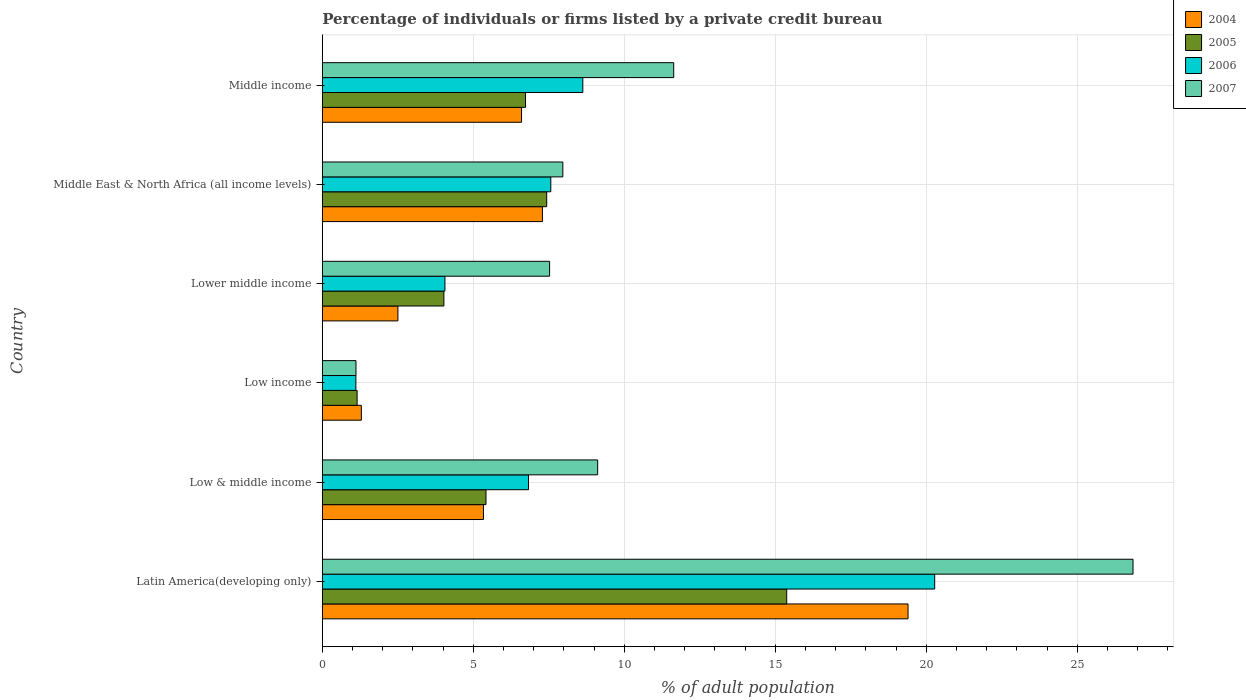How many different coloured bars are there?
Your response must be concise. 4. How many groups of bars are there?
Provide a short and direct response. 6. Are the number of bars on each tick of the Y-axis equal?
Ensure brevity in your answer.  Yes. How many bars are there on the 2nd tick from the top?
Offer a very short reply. 4. What is the label of the 6th group of bars from the top?
Your answer should be compact. Latin America(developing only). In how many cases, is the number of bars for a given country not equal to the number of legend labels?
Offer a very short reply. 0. What is the percentage of population listed by a private credit bureau in 2007 in Middle East & North Africa (all income levels)?
Your answer should be compact. 7.96. Across all countries, what is the maximum percentage of population listed by a private credit bureau in 2004?
Give a very brief answer. 19.39. Across all countries, what is the minimum percentage of population listed by a private credit bureau in 2004?
Give a very brief answer. 1.29. In which country was the percentage of population listed by a private credit bureau in 2004 maximum?
Give a very brief answer. Latin America(developing only). In which country was the percentage of population listed by a private credit bureau in 2005 minimum?
Your answer should be compact. Low income. What is the total percentage of population listed by a private credit bureau in 2004 in the graph?
Offer a terse response. 42.41. What is the difference between the percentage of population listed by a private credit bureau in 2004 in Low & middle income and that in Middle East & North Africa (all income levels)?
Make the answer very short. -1.95. What is the difference between the percentage of population listed by a private credit bureau in 2005 in Latin America(developing only) and the percentage of population listed by a private credit bureau in 2004 in Lower middle income?
Your answer should be very brief. 12.87. What is the average percentage of population listed by a private credit bureau in 2005 per country?
Provide a succinct answer. 6.69. What is the difference between the percentage of population listed by a private credit bureau in 2006 and percentage of population listed by a private credit bureau in 2005 in Low income?
Your answer should be very brief. -0.04. What is the ratio of the percentage of population listed by a private credit bureau in 2004 in Latin America(developing only) to that in Lower middle income?
Give a very brief answer. 7.75. Is the percentage of population listed by a private credit bureau in 2004 in Low income less than that in Middle East & North Africa (all income levels)?
Give a very brief answer. Yes. What is the difference between the highest and the second highest percentage of population listed by a private credit bureau in 2007?
Give a very brief answer. 15.21. What is the difference between the highest and the lowest percentage of population listed by a private credit bureau in 2007?
Provide a short and direct response. 25.73. In how many countries, is the percentage of population listed by a private credit bureau in 2007 greater than the average percentage of population listed by a private credit bureau in 2007 taken over all countries?
Keep it short and to the point. 2. Is it the case that in every country, the sum of the percentage of population listed by a private credit bureau in 2007 and percentage of population listed by a private credit bureau in 2005 is greater than the sum of percentage of population listed by a private credit bureau in 2004 and percentage of population listed by a private credit bureau in 2006?
Your response must be concise. No. What does the 2nd bar from the top in Low income represents?
Your answer should be compact. 2006. What does the 3rd bar from the bottom in Middle income represents?
Your answer should be very brief. 2006. How many bars are there?
Your response must be concise. 24. How many countries are there in the graph?
Offer a terse response. 6. What is the difference between two consecutive major ticks on the X-axis?
Make the answer very short. 5. Are the values on the major ticks of X-axis written in scientific E-notation?
Your answer should be very brief. No. Does the graph contain any zero values?
Offer a terse response. No. Does the graph contain grids?
Ensure brevity in your answer.  Yes. Where does the legend appear in the graph?
Make the answer very short. Top right. How many legend labels are there?
Your answer should be compact. 4. What is the title of the graph?
Offer a very short reply. Percentage of individuals or firms listed by a private credit bureau. Does "1992" appear as one of the legend labels in the graph?
Your answer should be compact. No. What is the label or title of the X-axis?
Your answer should be very brief. % of adult population. What is the label or title of the Y-axis?
Make the answer very short. Country. What is the % of adult population in 2004 in Latin America(developing only)?
Offer a terse response. 19.39. What is the % of adult population of 2005 in Latin America(developing only)?
Your answer should be very brief. 15.38. What is the % of adult population in 2006 in Latin America(developing only)?
Offer a very short reply. 20.28. What is the % of adult population of 2007 in Latin America(developing only)?
Offer a very short reply. 26.84. What is the % of adult population in 2004 in Low & middle income?
Your response must be concise. 5.34. What is the % of adult population of 2005 in Low & middle income?
Your answer should be very brief. 5.42. What is the % of adult population in 2006 in Low & middle income?
Your answer should be compact. 6.83. What is the % of adult population in 2007 in Low & middle income?
Give a very brief answer. 9.12. What is the % of adult population of 2004 in Low income?
Give a very brief answer. 1.29. What is the % of adult population in 2005 in Low income?
Provide a succinct answer. 1.15. What is the % of adult population of 2006 in Low income?
Your response must be concise. 1.11. What is the % of adult population of 2007 in Low income?
Your response must be concise. 1.11. What is the % of adult population of 2004 in Lower middle income?
Make the answer very short. 2.5. What is the % of adult population in 2005 in Lower middle income?
Offer a terse response. 4.03. What is the % of adult population in 2006 in Lower middle income?
Give a very brief answer. 4.06. What is the % of adult population of 2007 in Lower middle income?
Give a very brief answer. 7.53. What is the % of adult population of 2004 in Middle East & North Africa (all income levels)?
Make the answer very short. 7.29. What is the % of adult population in 2005 in Middle East & North Africa (all income levels)?
Provide a short and direct response. 7.43. What is the % of adult population of 2006 in Middle East & North Africa (all income levels)?
Your answer should be compact. 7.56. What is the % of adult population in 2007 in Middle East & North Africa (all income levels)?
Offer a very short reply. 7.96. What is the % of adult population in 2004 in Middle income?
Your answer should be very brief. 6.6. What is the % of adult population in 2005 in Middle income?
Make the answer very short. 6.73. What is the % of adult population in 2006 in Middle income?
Keep it short and to the point. 8.62. What is the % of adult population in 2007 in Middle income?
Ensure brevity in your answer.  11.63. Across all countries, what is the maximum % of adult population of 2004?
Provide a succinct answer. 19.39. Across all countries, what is the maximum % of adult population in 2005?
Give a very brief answer. 15.38. Across all countries, what is the maximum % of adult population of 2006?
Make the answer very short. 20.28. Across all countries, what is the maximum % of adult population in 2007?
Ensure brevity in your answer.  26.84. Across all countries, what is the minimum % of adult population in 2004?
Give a very brief answer. 1.29. Across all countries, what is the minimum % of adult population of 2005?
Make the answer very short. 1.15. Across all countries, what is the minimum % of adult population of 2006?
Your answer should be compact. 1.11. Across all countries, what is the minimum % of adult population in 2007?
Your answer should be very brief. 1.11. What is the total % of adult population in 2004 in the graph?
Ensure brevity in your answer.  42.41. What is the total % of adult population in 2005 in the graph?
Offer a terse response. 40.13. What is the total % of adult population of 2006 in the graph?
Your response must be concise. 48.46. What is the total % of adult population in 2007 in the graph?
Offer a very short reply. 64.2. What is the difference between the % of adult population in 2004 in Latin America(developing only) and that in Low & middle income?
Provide a succinct answer. 14.06. What is the difference between the % of adult population in 2005 in Latin America(developing only) and that in Low & middle income?
Give a very brief answer. 9.96. What is the difference between the % of adult population in 2006 in Latin America(developing only) and that in Low & middle income?
Make the answer very short. 13.45. What is the difference between the % of adult population in 2007 in Latin America(developing only) and that in Low & middle income?
Offer a very short reply. 17.73. What is the difference between the % of adult population in 2004 in Latin America(developing only) and that in Low income?
Your answer should be very brief. 18.1. What is the difference between the % of adult population of 2005 in Latin America(developing only) and that in Low income?
Your answer should be compact. 14.22. What is the difference between the % of adult population in 2006 in Latin America(developing only) and that in Low income?
Give a very brief answer. 19.17. What is the difference between the % of adult population of 2007 in Latin America(developing only) and that in Low income?
Offer a very short reply. 25.73. What is the difference between the % of adult population of 2004 in Latin America(developing only) and that in Lower middle income?
Your answer should be very brief. 16.89. What is the difference between the % of adult population in 2005 in Latin America(developing only) and that in Lower middle income?
Ensure brevity in your answer.  11.35. What is the difference between the % of adult population of 2006 in Latin America(developing only) and that in Lower middle income?
Make the answer very short. 16.22. What is the difference between the % of adult population of 2007 in Latin America(developing only) and that in Lower middle income?
Keep it short and to the point. 19.32. What is the difference between the % of adult population of 2004 in Latin America(developing only) and that in Middle East & North Africa (all income levels)?
Give a very brief answer. 12.11. What is the difference between the % of adult population in 2005 in Latin America(developing only) and that in Middle East & North Africa (all income levels)?
Your answer should be very brief. 7.95. What is the difference between the % of adult population of 2006 in Latin America(developing only) and that in Middle East & North Africa (all income levels)?
Keep it short and to the point. 12.71. What is the difference between the % of adult population in 2007 in Latin America(developing only) and that in Middle East & North Africa (all income levels)?
Offer a very short reply. 18.88. What is the difference between the % of adult population of 2004 in Latin America(developing only) and that in Middle income?
Provide a short and direct response. 12.8. What is the difference between the % of adult population of 2005 in Latin America(developing only) and that in Middle income?
Your response must be concise. 8.65. What is the difference between the % of adult population in 2006 in Latin America(developing only) and that in Middle income?
Keep it short and to the point. 11.65. What is the difference between the % of adult population in 2007 in Latin America(developing only) and that in Middle income?
Keep it short and to the point. 15.21. What is the difference between the % of adult population in 2004 in Low & middle income and that in Low income?
Provide a short and direct response. 4.04. What is the difference between the % of adult population of 2005 in Low & middle income and that in Low income?
Provide a short and direct response. 4.27. What is the difference between the % of adult population in 2006 in Low & middle income and that in Low income?
Offer a terse response. 5.72. What is the difference between the % of adult population of 2007 in Low & middle income and that in Low income?
Provide a succinct answer. 8. What is the difference between the % of adult population of 2004 in Low & middle income and that in Lower middle income?
Offer a terse response. 2.83. What is the difference between the % of adult population in 2005 in Low & middle income and that in Lower middle income?
Give a very brief answer. 1.39. What is the difference between the % of adult population of 2006 in Low & middle income and that in Lower middle income?
Your answer should be compact. 2.77. What is the difference between the % of adult population in 2007 in Low & middle income and that in Lower middle income?
Your response must be concise. 1.59. What is the difference between the % of adult population of 2004 in Low & middle income and that in Middle East & North Africa (all income levels)?
Offer a terse response. -1.95. What is the difference between the % of adult population of 2005 in Low & middle income and that in Middle East & North Africa (all income levels)?
Provide a short and direct response. -2.01. What is the difference between the % of adult population of 2006 in Low & middle income and that in Middle East & North Africa (all income levels)?
Provide a succinct answer. -0.74. What is the difference between the % of adult population of 2007 in Low & middle income and that in Middle East & North Africa (all income levels)?
Your answer should be very brief. 1.15. What is the difference between the % of adult population of 2004 in Low & middle income and that in Middle income?
Offer a very short reply. -1.26. What is the difference between the % of adult population in 2005 in Low & middle income and that in Middle income?
Keep it short and to the point. -1.31. What is the difference between the % of adult population of 2006 in Low & middle income and that in Middle income?
Offer a very short reply. -1.8. What is the difference between the % of adult population of 2007 in Low & middle income and that in Middle income?
Provide a short and direct response. -2.52. What is the difference between the % of adult population in 2004 in Low income and that in Lower middle income?
Keep it short and to the point. -1.21. What is the difference between the % of adult population of 2005 in Low income and that in Lower middle income?
Make the answer very short. -2.87. What is the difference between the % of adult population of 2006 in Low income and that in Lower middle income?
Offer a very short reply. -2.95. What is the difference between the % of adult population of 2007 in Low income and that in Lower middle income?
Provide a succinct answer. -6.41. What is the difference between the % of adult population of 2004 in Low income and that in Middle East & North Africa (all income levels)?
Keep it short and to the point. -6. What is the difference between the % of adult population in 2005 in Low income and that in Middle East & North Africa (all income levels)?
Offer a very short reply. -6.28. What is the difference between the % of adult population of 2006 in Low income and that in Middle East & North Africa (all income levels)?
Offer a very short reply. -6.45. What is the difference between the % of adult population in 2007 in Low income and that in Middle East & North Africa (all income levels)?
Make the answer very short. -6.85. What is the difference between the % of adult population in 2004 in Low income and that in Middle income?
Provide a short and direct response. -5.3. What is the difference between the % of adult population of 2005 in Low income and that in Middle income?
Make the answer very short. -5.58. What is the difference between the % of adult population in 2006 in Low income and that in Middle income?
Your response must be concise. -7.51. What is the difference between the % of adult population in 2007 in Low income and that in Middle income?
Keep it short and to the point. -10.52. What is the difference between the % of adult population in 2004 in Lower middle income and that in Middle East & North Africa (all income levels)?
Offer a very short reply. -4.79. What is the difference between the % of adult population in 2005 in Lower middle income and that in Middle East & North Africa (all income levels)?
Your answer should be very brief. -3.4. What is the difference between the % of adult population in 2006 in Lower middle income and that in Middle East & North Africa (all income levels)?
Offer a terse response. -3.51. What is the difference between the % of adult population of 2007 in Lower middle income and that in Middle East & North Africa (all income levels)?
Your answer should be very brief. -0.44. What is the difference between the % of adult population of 2004 in Lower middle income and that in Middle income?
Ensure brevity in your answer.  -4.09. What is the difference between the % of adult population of 2005 in Lower middle income and that in Middle income?
Offer a very short reply. -2.7. What is the difference between the % of adult population of 2006 in Lower middle income and that in Middle income?
Your answer should be very brief. -4.57. What is the difference between the % of adult population in 2007 in Lower middle income and that in Middle income?
Offer a very short reply. -4.11. What is the difference between the % of adult population in 2004 in Middle East & North Africa (all income levels) and that in Middle income?
Provide a succinct answer. 0.69. What is the difference between the % of adult population of 2005 in Middle East & North Africa (all income levels) and that in Middle income?
Ensure brevity in your answer.  0.7. What is the difference between the % of adult population in 2006 in Middle East & North Africa (all income levels) and that in Middle income?
Offer a very short reply. -1.06. What is the difference between the % of adult population of 2007 in Middle East & North Africa (all income levels) and that in Middle income?
Your response must be concise. -3.67. What is the difference between the % of adult population in 2004 in Latin America(developing only) and the % of adult population in 2005 in Low & middle income?
Offer a very short reply. 13.97. What is the difference between the % of adult population in 2004 in Latin America(developing only) and the % of adult population in 2006 in Low & middle income?
Give a very brief answer. 12.57. What is the difference between the % of adult population in 2004 in Latin America(developing only) and the % of adult population in 2007 in Low & middle income?
Offer a terse response. 10.28. What is the difference between the % of adult population in 2005 in Latin America(developing only) and the % of adult population in 2006 in Low & middle income?
Provide a short and direct response. 8.55. What is the difference between the % of adult population of 2005 in Latin America(developing only) and the % of adult population of 2007 in Low & middle income?
Provide a short and direct response. 6.26. What is the difference between the % of adult population in 2006 in Latin America(developing only) and the % of adult population in 2007 in Low & middle income?
Ensure brevity in your answer.  11.16. What is the difference between the % of adult population of 2004 in Latin America(developing only) and the % of adult population of 2005 in Low income?
Ensure brevity in your answer.  18.24. What is the difference between the % of adult population in 2004 in Latin America(developing only) and the % of adult population in 2006 in Low income?
Your response must be concise. 18.28. What is the difference between the % of adult population in 2004 in Latin America(developing only) and the % of adult population in 2007 in Low income?
Provide a short and direct response. 18.28. What is the difference between the % of adult population of 2005 in Latin America(developing only) and the % of adult population of 2006 in Low income?
Offer a terse response. 14.27. What is the difference between the % of adult population of 2005 in Latin America(developing only) and the % of adult population of 2007 in Low income?
Ensure brevity in your answer.  14.26. What is the difference between the % of adult population in 2006 in Latin America(developing only) and the % of adult population in 2007 in Low income?
Your answer should be very brief. 19.16. What is the difference between the % of adult population in 2004 in Latin America(developing only) and the % of adult population in 2005 in Lower middle income?
Give a very brief answer. 15.37. What is the difference between the % of adult population of 2004 in Latin America(developing only) and the % of adult population of 2006 in Lower middle income?
Your answer should be compact. 15.33. What is the difference between the % of adult population of 2004 in Latin America(developing only) and the % of adult population of 2007 in Lower middle income?
Your answer should be very brief. 11.87. What is the difference between the % of adult population of 2005 in Latin America(developing only) and the % of adult population of 2006 in Lower middle income?
Give a very brief answer. 11.32. What is the difference between the % of adult population of 2005 in Latin America(developing only) and the % of adult population of 2007 in Lower middle income?
Your answer should be very brief. 7.85. What is the difference between the % of adult population of 2006 in Latin America(developing only) and the % of adult population of 2007 in Lower middle income?
Your response must be concise. 12.75. What is the difference between the % of adult population in 2004 in Latin America(developing only) and the % of adult population in 2005 in Middle East & North Africa (all income levels)?
Ensure brevity in your answer.  11.96. What is the difference between the % of adult population of 2004 in Latin America(developing only) and the % of adult population of 2006 in Middle East & North Africa (all income levels)?
Your answer should be compact. 11.83. What is the difference between the % of adult population of 2004 in Latin America(developing only) and the % of adult population of 2007 in Middle East & North Africa (all income levels)?
Give a very brief answer. 11.43. What is the difference between the % of adult population in 2005 in Latin America(developing only) and the % of adult population in 2006 in Middle East & North Africa (all income levels)?
Offer a very short reply. 7.81. What is the difference between the % of adult population in 2005 in Latin America(developing only) and the % of adult population in 2007 in Middle East & North Africa (all income levels)?
Ensure brevity in your answer.  7.41. What is the difference between the % of adult population in 2006 in Latin America(developing only) and the % of adult population in 2007 in Middle East & North Africa (all income levels)?
Provide a short and direct response. 12.31. What is the difference between the % of adult population in 2004 in Latin America(developing only) and the % of adult population in 2005 in Middle income?
Your answer should be compact. 12.66. What is the difference between the % of adult population of 2004 in Latin America(developing only) and the % of adult population of 2006 in Middle income?
Your answer should be very brief. 10.77. What is the difference between the % of adult population of 2004 in Latin America(developing only) and the % of adult population of 2007 in Middle income?
Make the answer very short. 7.76. What is the difference between the % of adult population in 2005 in Latin America(developing only) and the % of adult population in 2006 in Middle income?
Your answer should be compact. 6.75. What is the difference between the % of adult population of 2005 in Latin America(developing only) and the % of adult population of 2007 in Middle income?
Make the answer very short. 3.74. What is the difference between the % of adult population of 2006 in Latin America(developing only) and the % of adult population of 2007 in Middle income?
Your answer should be very brief. 8.64. What is the difference between the % of adult population of 2004 in Low & middle income and the % of adult population of 2005 in Low income?
Give a very brief answer. 4.18. What is the difference between the % of adult population in 2004 in Low & middle income and the % of adult population in 2006 in Low income?
Your response must be concise. 4.22. What is the difference between the % of adult population of 2004 in Low & middle income and the % of adult population of 2007 in Low income?
Your response must be concise. 4.22. What is the difference between the % of adult population of 2005 in Low & middle income and the % of adult population of 2006 in Low income?
Your response must be concise. 4.31. What is the difference between the % of adult population of 2005 in Low & middle income and the % of adult population of 2007 in Low income?
Offer a very short reply. 4.3. What is the difference between the % of adult population in 2006 in Low & middle income and the % of adult population in 2007 in Low income?
Provide a short and direct response. 5.71. What is the difference between the % of adult population of 2004 in Low & middle income and the % of adult population of 2005 in Lower middle income?
Your answer should be compact. 1.31. What is the difference between the % of adult population of 2004 in Low & middle income and the % of adult population of 2006 in Lower middle income?
Ensure brevity in your answer.  1.28. What is the difference between the % of adult population in 2004 in Low & middle income and the % of adult population in 2007 in Lower middle income?
Your response must be concise. -2.19. What is the difference between the % of adult population of 2005 in Low & middle income and the % of adult population of 2006 in Lower middle income?
Give a very brief answer. 1.36. What is the difference between the % of adult population of 2005 in Low & middle income and the % of adult population of 2007 in Lower middle income?
Offer a terse response. -2.11. What is the difference between the % of adult population of 2006 in Low & middle income and the % of adult population of 2007 in Lower middle income?
Keep it short and to the point. -0.7. What is the difference between the % of adult population in 2004 in Low & middle income and the % of adult population in 2005 in Middle East & North Africa (all income levels)?
Your answer should be compact. -2.09. What is the difference between the % of adult population of 2004 in Low & middle income and the % of adult population of 2006 in Middle East & North Africa (all income levels)?
Make the answer very short. -2.23. What is the difference between the % of adult population in 2004 in Low & middle income and the % of adult population in 2007 in Middle East & North Africa (all income levels)?
Ensure brevity in your answer.  -2.63. What is the difference between the % of adult population in 2005 in Low & middle income and the % of adult population in 2006 in Middle East & North Africa (all income levels)?
Offer a terse response. -2.15. What is the difference between the % of adult population of 2005 in Low & middle income and the % of adult population of 2007 in Middle East & North Africa (all income levels)?
Keep it short and to the point. -2.54. What is the difference between the % of adult population in 2006 in Low & middle income and the % of adult population in 2007 in Middle East & North Africa (all income levels)?
Your answer should be compact. -1.14. What is the difference between the % of adult population of 2004 in Low & middle income and the % of adult population of 2005 in Middle income?
Give a very brief answer. -1.39. What is the difference between the % of adult population in 2004 in Low & middle income and the % of adult population in 2006 in Middle income?
Give a very brief answer. -3.29. What is the difference between the % of adult population of 2004 in Low & middle income and the % of adult population of 2007 in Middle income?
Your response must be concise. -6.3. What is the difference between the % of adult population in 2005 in Low & middle income and the % of adult population in 2006 in Middle income?
Your answer should be very brief. -3.21. What is the difference between the % of adult population of 2005 in Low & middle income and the % of adult population of 2007 in Middle income?
Your answer should be compact. -6.22. What is the difference between the % of adult population in 2006 in Low & middle income and the % of adult population in 2007 in Middle income?
Your answer should be compact. -4.81. What is the difference between the % of adult population of 2004 in Low income and the % of adult population of 2005 in Lower middle income?
Provide a short and direct response. -2.73. What is the difference between the % of adult population in 2004 in Low income and the % of adult population in 2006 in Lower middle income?
Your answer should be very brief. -2.77. What is the difference between the % of adult population in 2004 in Low income and the % of adult population in 2007 in Lower middle income?
Offer a terse response. -6.23. What is the difference between the % of adult population in 2005 in Low income and the % of adult population in 2006 in Lower middle income?
Offer a very short reply. -2.91. What is the difference between the % of adult population of 2005 in Low income and the % of adult population of 2007 in Lower middle income?
Your response must be concise. -6.37. What is the difference between the % of adult population in 2006 in Low income and the % of adult population in 2007 in Lower middle income?
Make the answer very short. -6.41. What is the difference between the % of adult population in 2004 in Low income and the % of adult population in 2005 in Middle East & North Africa (all income levels)?
Provide a succinct answer. -6.14. What is the difference between the % of adult population of 2004 in Low income and the % of adult population of 2006 in Middle East & North Africa (all income levels)?
Your answer should be very brief. -6.27. What is the difference between the % of adult population in 2004 in Low income and the % of adult population in 2007 in Middle East & North Africa (all income levels)?
Your answer should be compact. -6.67. What is the difference between the % of adult population of 2005 in Low income and the % of adult population of 2006 in Middle East & North Africa (all income levels)?
Provide a succinct answer. -6.41. What is the difference between the % of adult population of 2005 in Low income and the % of adult population of 2007 in Middle East & North Africa (all income levels)?
Your answer should be compact. -6.81. What is the difference between the % of adult population of 2006 in Low income and the % of adult population of 2007 in Middle East & North Africa (all income levels)?
Ensure brevity in your answer.  -6.85. What is the difference between the % of adult population in 2004 in Low income and the % of adult population in 2005 in Middle income?
Give a very brief answer. -5.44. What is the difference between the % of adult population in 2004 in Low income and the % of adult population in 2006 in Middle income?
Provide a short and direct response. -7.33. What is the difference between the % of adult population of 2004 in Low income and the % of adult population of 2007 in Middle income?
Provide a succinct answer. -10.34. What is the difference between the % of adult population of 2005 in Low income and the % of adult population of 2006 in Middle income?
Provide a short and direct response. -7.47. What is the difference between the % of adult population of 2005 in Low income and the % of adult population of 2007 in Middle income?
Provide a succinct answer. -10.48. What is the difference between the % of adult population of 2006 in Low income and the % of adult population of 2007 in Middle income?
Ensure brevity in your answer.  -10.52. What is the difference between the % of adult population of 2004 in Lower middle income and the % of adult population of 2005 in Middle East & North Africa (all income levels)?
Your response must be concise. -4.93. What is the difference between the % of adult population of 2004 in Lower middle income and the % of adult population of 2006 in Middle East & North Africa (all income levels)?
Offer a terse response. -5.06. What is the difference between the % of adult population of 2004 in Lower middle income and the % of adult population of 2007 in Middle East & North Africa (all income levels)?
Ensure brevity in your answer.  -5.46. What is the difference between the % of adult population of 2005 in Lower middle income and the % of adult population of 2006 in Middle East & North Africa (all income levels)?
Offer a very short reply. -3.54. What is the difference between the % of adult population in 2005 in Lower middle income and the % of adult population in 2007 in Middle East & North Africa (all income levels)?
Provide a succinct answer. -3.94. What is the difference between the % of adult population in 2006 in Lower middle income and the % of adult population in 2007 in Middle East & North Africa (all income levels)?
Provide a short and direct response. -3.9. What is the difference between the % of adult population of 2004 in Lower middle income and the % of adult population of 2005 in Middle income?
Keep it short and to the point. -4.23. What is the difference between the % of adult population of 2004 in Lower middle income and the % of adult population of 2006 in Middle income?
Your answer should be very brief. -6.12. What is the difference between the % of adult population of 2004 in Lower middle income and the % of adult population of 2007 in Middle income?
Offer a very short reply. -9.13. What is the difference between the % of adult population of 2005 in Lower middle income and the % of adult population of 2006 in Middle income?
Keep it short and to the point. -4.6. What is the difference between the % of adult population of 2005 in Lower middle income and the % of adult population of 2007 in Middle income?
Keep it short and to the point. -7.61. What is the difference between the % of adult population in 2006 in Lower middle income and the % of adult population in 2007 in Middle income?
Provide a succinct answer. -7.58. What is the difference between the % of adult population in 2004 in Middle East & North Africa (all income levels) and the % of adult population in 2005 in Middle income?
Give a very brief answer. 0.56. What is the difference between the % of adult population of 2004 in Middle East & North Africa (all income levels) and the % of adult population of 2006 in Middle income?
Your response must be concise. -1.34. What is the difference between the % of adult population in 2004 in Middle East & North Africa (all income levels) and the % of adult population in 2007 in Middle income?
Your answer should be very brief. -4.35. What is the difference between the % of adult population in 2005 in Middle East & North Africa (all income levels) and the % of adult population in 2006 in Middle income?
Offer a terse response. -1.2. What is the difference between the % of adult population in 2005 in Middle East & North Africa (all income levels) and the % of adult population in 2007 in Middle income?
Ensure brevity in your answer.  -4.21. What is the difference between the % of adult population in 2006 in Middle East & North Africa (all income levels) and the % of adult population in 2007 in Middle income?
Offer a very short reply. -4.07. What is the average % of adult population of 2004 per country?
Your answer should be compact. 7.07. What is the average % of adult population of 2005 per country?
Your answer should be very brief. 6.69. What is the average % of adult population of 2006 per country?
Provide a succinct answer. 8.08. What is the average % of adult population in 2007 per country?
Your answer should be compact. 10.7. What is the difference between the % of adult population in 2004 and % of adult population in 2005 in Latin America(developing only)?
Your answer should be very brief. 4.02. What is the difference between the % of adult population in 2004 and % of adult population in 2006 in Latin America(developing only)?
Your answer should be very brief. -0.88. What is the difference between the % of adult population of 2004 and % of adult population of 2007 in Latin America(developing only)?
Your answer should be very brief. -7.45. What is the difference between the % of adult population of 2005 and % of adult population of 2006 in Latin America(developing only)?
Provide a short and direct response. -4.9. What is the difference between the % of adult population of 2005 and % of adult population of 2007 in Latin America(developing only)?
Provide a short and direct response. -11.47. What is the difference between the % of adult population in 2006 and % of adult population in 2007 in Latin America(developing only)?
Your answer should be compact. -6.57. What is the difference between the % of adult population in 2004 and % of adult population in 2005 in Low & middle income?
Offer a terse response. -0.08. What is the difference between the % of adult population of 2004 and % of adult population of 2006 in Low & middle income?
Ensure brevity in your answer.  -1.49. What is the difference between the % of adult population of 2004 and % of adult population of 2007 in Low & middle income?
Your response must be concise. -3.78. What is the difference between the % of adult population of 2005 and % of adult population of 2006 in Low & middle income?
Provide a succinct answer. -1.41. What is the difference between the % of adult population of 2005 and % of adult population of 2007 in Low & middle income?
Offer a terse response. -3.7. What is the difference between the % of adult population in 2006 and % of adult population in 2007 in Low & middle income?
Keep it short and to the point. -2.29. What is the difference between the % of adult population in 2004 and % of adult population in 2005 in Low income?
Your response must be concise. 0.14. What is the difference between the % of adult population in 2004 and % of adult population in 2006 in Low income?
Your response must be concise. 0.18. What is the difference between the % of adult population of 2004 and % of adult population of 2007 in Low income?
Offer a terse response. 0.18. What is the difference between the % of adult population of 2005 and % of adult population of 2006 in Low income?
Your answer should be compact. 0.04. What is the difference between the % of adult population in 2005 and % of adult population in 2007 in Low income?
Offer a terse response. 0.04. What is the difference between the % of adult population of 2006 and % of adult population of 2007 in Low income?
Your answer should be very brief. -0. What is the difference between the % of adult population in 2004 and % of adult population in 2005 in Lower middle income?
Your answer should be very brief. -1.52. What is the difference between the % of adult population of 2004 and % of adult population of 2006 in Lower middle income?
Provide a succinct answer. -1.56. What is the difference between the % of adult population in 2004 and % of adult population in 2007 in Lower middle income?
Provide a succinct answer. -5.02. What is the difference between the % of adult population of 2005 and % of adult population of 2006 in Lower middle income?
Make the answer very short. -0.03. What is the difference between the % of adult population in 2005 and % of adult population in 2007 in Lower middle income?
Your answer should be compact. -3.5. What is the difference between the % of adult population of 2006 and % of adult population of 2007 in Lower middle income?
Offer a very short reply. -3.47. What is the difference between the % of adult population in 2004 and % of adult population in 2005 in Middle East & North Africa (all income levels)?
Offer a terse response. -0.14. What is the difference between the % of adult population in 2004 and % of adult population in 2006 in Middle East & North Africa (all income levels)?
Your response must be concise. -0.28. What is the difference between the % of adult population of 2004 and % of adult population of 2007 in Middle East & North Africa (all income levels)?
Provide a succinct answer. -0.68. What is the difference between the % of adult population in 2005 and % of adult population in 2006 in Middle East & North Africa (all income levels)?
Offer a terse response. -0.14. What is the difference between the % of adult population of 2005 and % of adult population of 2007 in Middle East & North Africa (all income levels)?
Keep it short and to the point. -0.53. What is the difference between the % of adult population of 2006 and % of adult population of 2007 in Middle East & North Africa (all income levels)?
Your answer should be compact. -0.4. What is the difference between the % of adult population of 2004 and % of adult population of 2005 in Middle income?
Offer a very short reply. -0.13. What is the difference between the % of adult population in 2004 and % of adult population in 2006 in Middle income?
Make the answer very short. -2.03. What is the difference between the % of adult population in 2004 and % of adult population in 2007 in Middle income?
Give a very brief answer. -5.04. What is the difference between the % of adult population of 2005 and % of adult population of 2006 in Middle income?
Ensure brevity in your answer.  -1.9. What is the difference between the % of adult population of 2005 and % of adult population of 2007 in Middle income?
Keep it short and to the point. -4.91. What is the difference between the % of adult population of 2006 and % of adult population of 2007 in Middle income?
Keep it short and to the point. -3.01. What is the ratio of the % of adult population of 2004 in Latin America(developing only) to that in Low & middle income?
Ensure brevity in your answer.  3.63. What is the ratio of the % of adult population in 2005 in Latin America(developing only) to that in Low & middle income?
Ensure brevity in your answer.  2.84. What is the ratio of the % of adult population in 2006 in Latin America(developing only) to that in Low & middle income?
Keep it short and to the point. 2.97. What is the ratio of the % of adult population in 2007 in Latin America(developing only) to that in Low & middle income?
Keep it short and to the point. 2.94. What is the ratio of the % of adult population of 2004 in Latin America(developing only) to that in Low income?
Ensure brevity in your answer.  15.01. What is the ratio of the % of adult population in 2005 in Latin America(developing only) to that in Low income?
Provide a short and direct response. 13.35. What is the ratio of the % of adult population in 2006 in Latin America(developing only) to that in Low income?
Your answer should be very brief. 18.26. What is the ratio of the % of adult population in 2007 in Latin America(developing only) to that in Low income?
Provide a succinct answer. 24.09. What is the ratio of the % of adult population in 2004 in Latin America(developing only) to that in Lower middle income?
Provide a short and direct response. 7.75. What is the ratio of the % of adult population of 2005 in Latin America(developing only) to that in Lower middle income?
Your answer should be compact. 3.82. What is the ratio of the % of adult population in 2006 in Latin America(developing only) to that in Lower middle income?
Provide a short and direct response. 5. What is the ratio of the % of adult population in 2007 in Latin America(developing only) to that in Lower middle income?
Provide a succinct answer. 3.57. What is the ratio of the % of adult population of 2004 in Latin America(developing only) to that in Middle East & North Africa (all income levels)?
Keep it short and to the point. 2.66. What is the ratio of the % of adult population in 2005 in Latin America(developing only) to that in Middle East & North Africa (all income levels)?
Keep it short and to the point. 2.07. What is the ratio of the % of adult population in 2006 in Latin America(developing only) to that in Middle East & North Africa (all income levels)?
Your answer should be very brief. 2.68. What is the ratio of the % of adult population of 2007 in Latin America(developing only) to that in Middle East & North Africa (all income levels)?
Keep it short and to the point. 3.37. What is the ratio of the % of adult population in 2004 in Latin America(developing only) to that in Middle income?
Ensure brevity in your answer.  2.94. What is the ratio of the % of adult population in 2005 in Latin America(developing only) to that in Middle income?
Offer a terse response. 2.29. What is the ratio of the % of adult population in 2006 in Latin America(developing only) to that in Middle income?
Your response must be concise. 2.35. What is the ratio of the % of adult population in 2007 in Latin America(developing only) to that in Middle income?
Offer a terse response. 2.31. What is the ratio of the % of adult population of 2004 in Low & middle income to that in Low income?
Ensure brevity in your answer.  4.13. What is the ratio of the % of adult population of 2005 in Low & middle income to that in Low income?
Make the answer very short. 4.7. What is the ratio of the % of adult population in 2006 in Low & middle income to that in Low income?
Make the answer very short. 6.15. What is the ratio of the % of adult population of 2007 in Low & middle income to that in Low income?
Your answer should be compact. 8.18. What is the ratio of the % of adult population in 2004 in Low & middle income to that in Lower middle income?
Provide a succinct answer. 2.13. What is the ratio of the % of adult population of 2005 in Low & middle income to that in Lower middle income?
Your response must be concise. 1.35. What is the ratio of the % of adult population in 2006 in Low & middle income to that in Lower middle income?
Keep it short and to the point. 1.68. What is the ratio of the % of adult population of 2007 in Low & middle income to that in Lower middle income?
Provide a short and direct response. 1.21. What is the ratio of the % of adult population in 2004 in Low & middle income to that in Middle East & North Africa (all income levels)?
Your answer should be very brief. 0.73. What is the ratio of the % of adult population of 2005 in Low & middle income to that in Middle East & North Africa (all income levels)?
Your answer should be compact. 0.73. What is the ratio of the % of adult population in 2006 in Low & middle income to that in Middle East & North Africa (all income levels)?
Keep it short and to the point. 0.9. What is the ratio of the % of adult population of 2007 in Low & middle income to that in Middle East & North Africa (all income levels)?
Your answer should be very brief. 1.14. What is the ratio of the % of adult population of 2004 in Low & middle income to that in Middle income?
Provide a short and direct response. 0.81. What is the ratio of the % of adult population of 2005 in Low & middle income to that in Middle income?
Keep it short and to the point. 0.81. What is the ratio of the % of adult population in 2006 in Low & middle income to that in Middle income?
Offer a terse response. 0.79. What is the ratio of the % of adult population of 2007 in Low & middle income to that in Middle income?
Offer a very short reply. 0.78. What is the ratio of the % of adult population in 2004 in Low income to that in Lower middle income?
Offer a terse response. 0.52. What is the ratio of the % of adult population of 2005 in Low income to that in Lower middle income?
Your answer should be compact. 0.29. What is the ratio of the % of adult population of 2006 in Low income to that in Lower middle income?
Offer a very short reply. 0.27. What is the ratio of the % of adult population of 2007 in Low income to that in Lower middle income?
Your answer should be compact. 0.15. What is the ratio of the % of adult population in 2004 in Low income to that in Middle East & North Africa (all income levels)?
Offer a very short reply. 0.18. What is the ratio of the % of adult population in 2005 in Low income to that in Middle East & North Africa (all income levels)?
Offer a very short reply. 0.15. What is the ratio of the % of adult population in 2006 in Low income to that in Middle East & North Africa (all income levels)?
Offer a terse response. 0.15. What is the ratio of the % of adult population in 2007 in Low income to that in Middle East & North Africa (all income levels)?
Your answer should be very brief. 0.14. What is the ratio of the % of adult population of 2004 in Low income to that in Middle income?
Keep it short and to the point. 0.2. What is the ratio of the % of adult population in 2005 in Low income to that in Middle income?
Ensure brevity in your answer.  0.17. What is the ratio of the % of adult population of 2006 in Low income to that in Middle income?
Your answer should be very brief. 0.13. What is the ratio of the % of adult population of 2007 in Low income to that in Middle income?
Your answer should be compact. 0.1. What is the ratio of the % of adult population in 2004 in Lower middle income to that in Middle East & North Africa (all income levels)?
Give a very brief answer. 0.34. What is the ratio of the % of adult population of 2005 in Lower middle income to that in Middle East & North Africa (all income levels)?
Your answer should be compact. 0.54. What is the ratio of the % of adult population of 2006 in Lower middle income to that in Middle East & North Africa (all income levels)?
Your answer should be very brief. 0.54. What is the ratio of the % of adult population in 2007 in Lower middle income to that in Middle East & North Africa (all income levels)?
Your answer should be very brief. 0.94. What is the ratio of the % of adult population in 2004 in Lower middle income to that in Middle income?
Offer a very short reply. 0.38. What is the ratio of the % of adult population of 2005 in Lower middle income to that in Middle income?
Give a very brief answer. 0.6. What is the ratio of the % of adult population in 2006 in Lower middle income to that in Middle income?
Give a very brief answer. 0.47. What is the ratio of the % of adult population of 2007 in Lower middle income to that in Middle income?
Keep it short and to the point. 0.65. What is the ratio of the % of adult population in 2004 in Middle East & North Africa (all income levels) to that in Middle income?
Keep it short and to the point. 1.1. What is the ratio of the % of adult population in 2005 in Middle East & North Africa (all income levels) to that in Middle income?
Your response must be concise. 1.1. What is the ratio of the % of adult population of 2006 in Middle East & North Africa (all income levels) to that in Middle income?
Your response must be concise. 0.88. What is the ratio of the % of adult population in 2007 in Middle East & North Africa (all income levels) to that in Middle income?
Ensure brevity in your answer.  0.68. What is the difference between the highest and the second highest % of adult population in 2004?
Your answer should be compact. 12.11. What is the difference between the highest and the second highest % of adult population in 2005?
Give a very brief answer. 7.95. What is the difference between the highest and the second highest % of adult population of 2006?
Your response must be concise. 11.65. What is the difference between the highest and the second highest % of adult population of 2007?
Keep it short and to the point. 15.21. What is the difference between the highest and the lowest % of adult population in 2004?
Offer a terse response. 18.1. What is the difference between the highest and the lowest % of adult population in 2005?
Provide a short and direct response. 14.22. What is the difference between the highest and the lowest % of adult population of 2006?
Offer a very short reply. 19.17. What is the difference between the highest and the lowest % of adult population in 2007?
Ensure brevity in your answer.  25.73. 